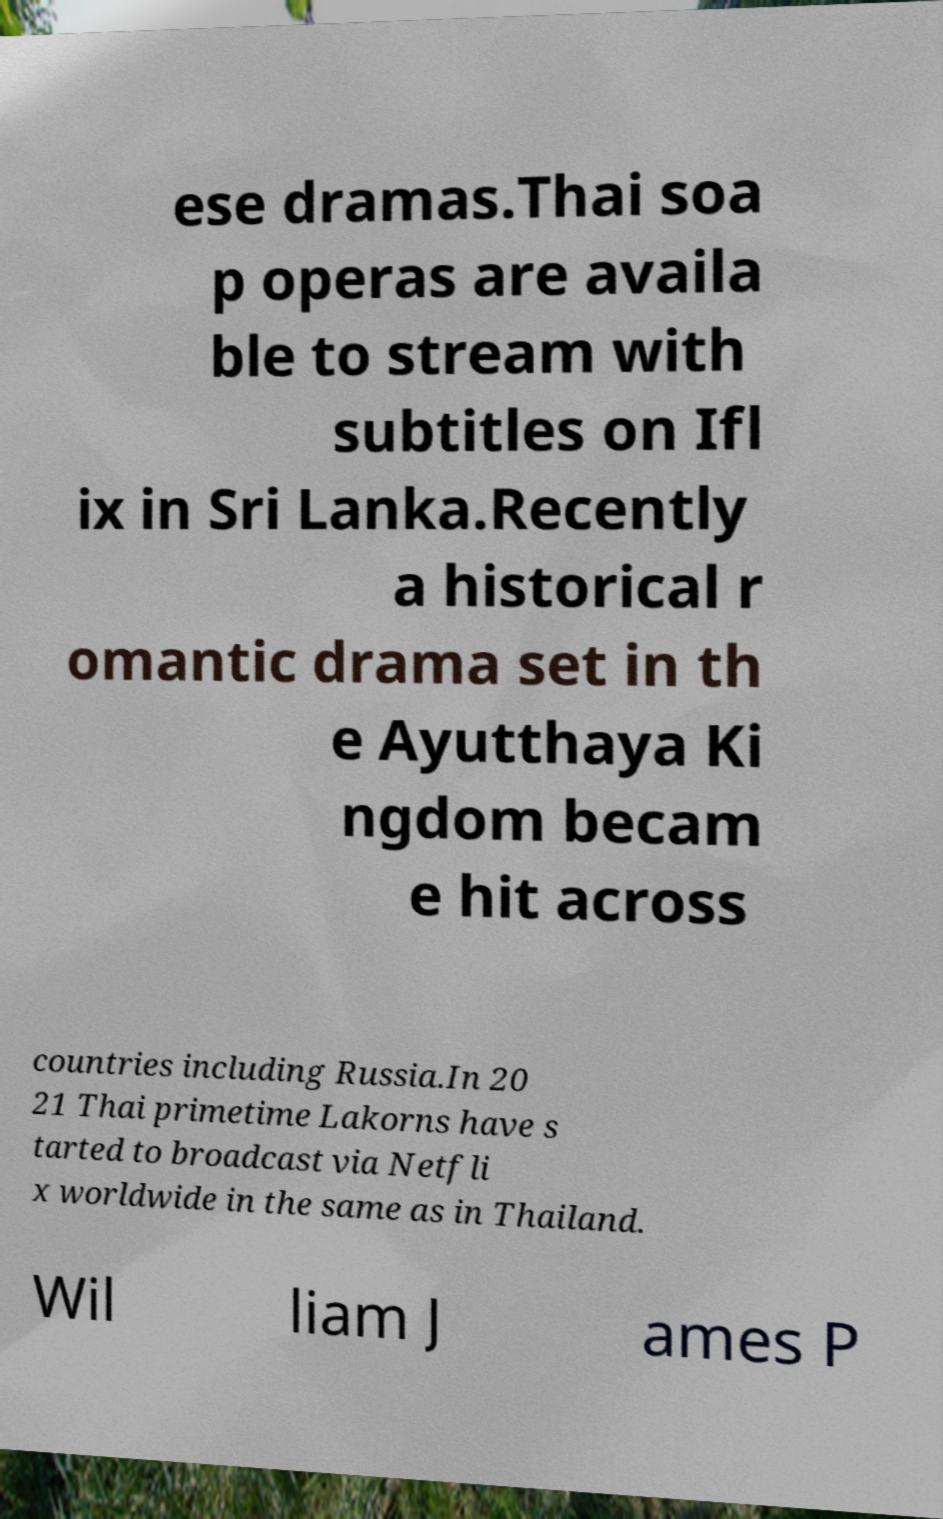I need the written content from this picture converted into text. Can you do that? ese dramas.Thai soa p operas are availa ble to stream with subtitles on Ifl ix in Sri Lanka.Recently a historical r omantic drama set in th e Ayutthaya Ki ngdom becam e hit across countries including Russia.In 20 21 Thai primetime Lakorns have s tarted to broadcast via Netfli x worldwide in the same as in Thailand. Wil liam J ames P 